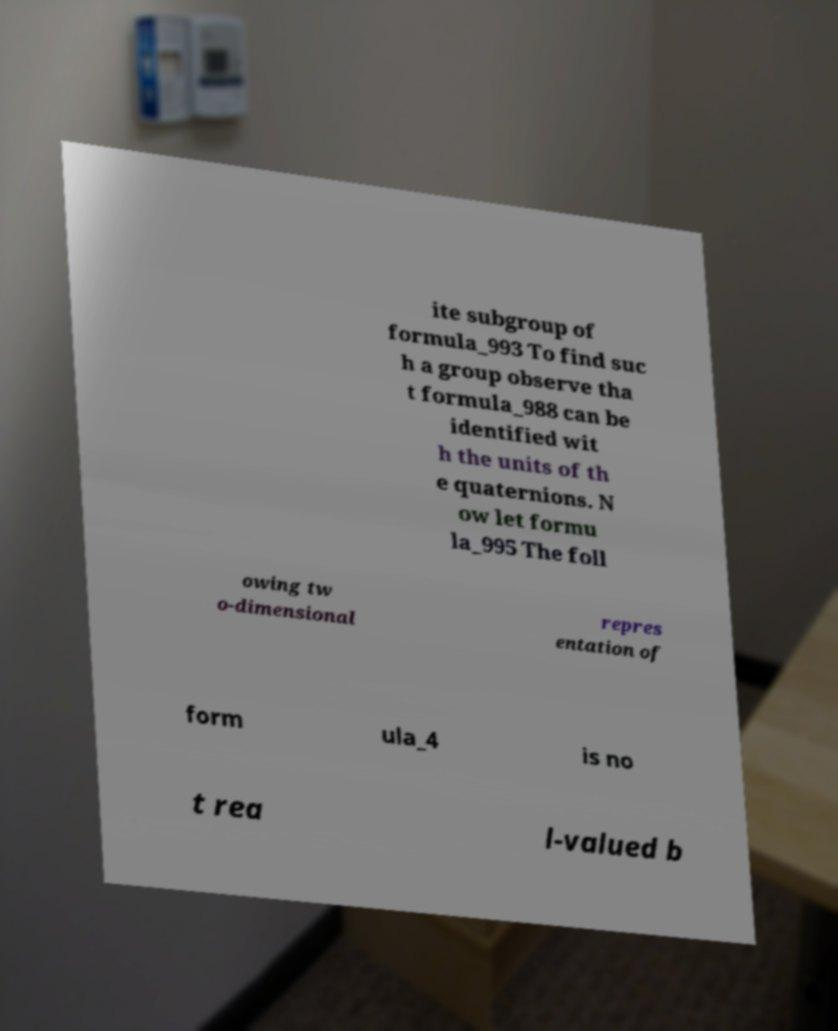What messages or text are displayed in this image? I need them in a readable, typed format. ite subgroup of formula_993 To find suc h a group observe tha t formula_988 can be identified wit h the units of th e quaternions. N ow let formu la_995 The foll owing tw o-dimensional repres entation of form ula_4 is no t rea l-valued b 